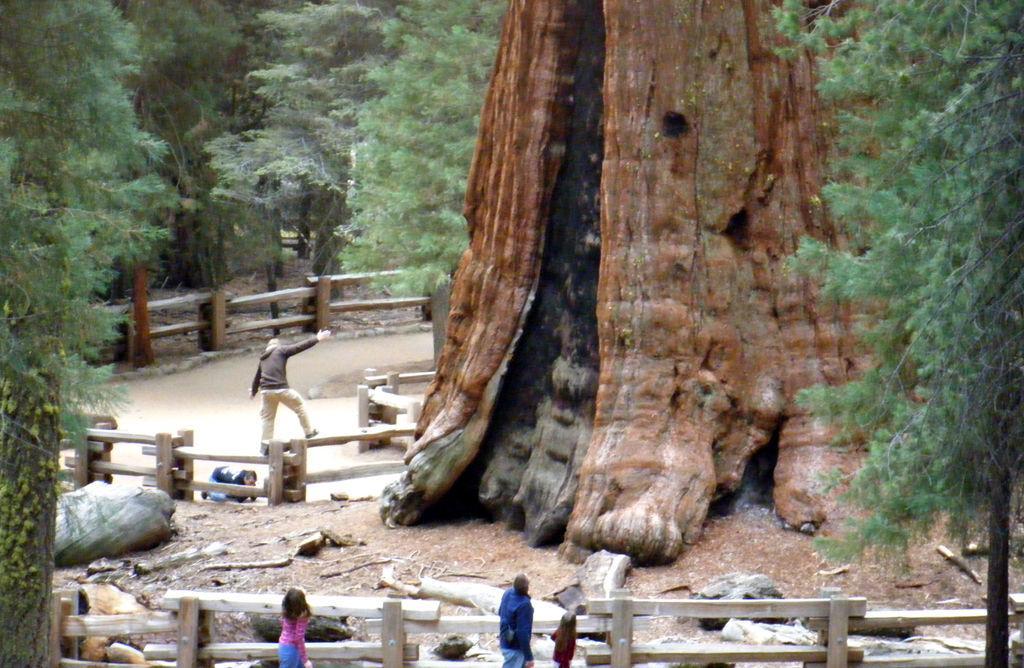Could you give a brief overview of what you see in this image? In this image I can see number of trees and I can also see few people are standing in the center of this image. 